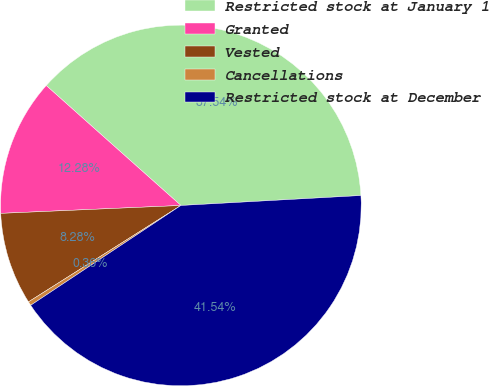<chart> <loc_0><loc_0><loc_500><loc_500><pie_chart><fcel>Restricted stock at January 1<fcel>Granted<fcel>Vested<fcel>Cancellations<fcel>Restricted stock at December<nl><fcel>37.54%<fcel>12.28%<fcel>8.28%<fcel>0.36%<fcel>41.54%<nl></chart> 